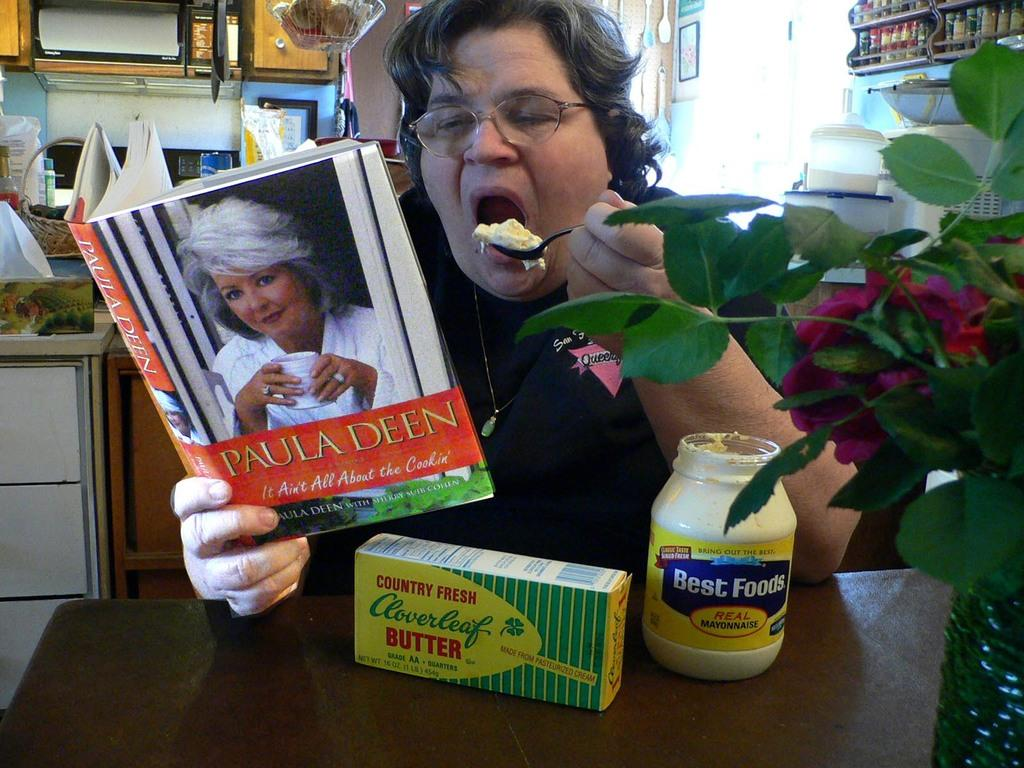<image>
Give a short and clear explanation of the subsequent image. The book that is being read is from Paula Deen 